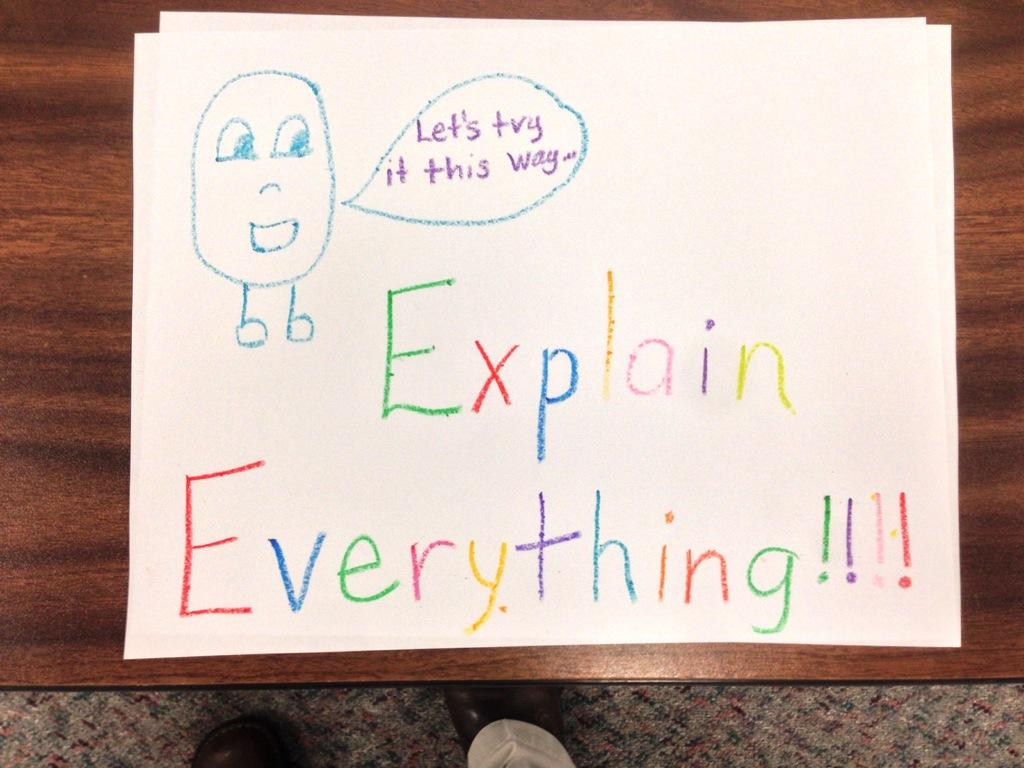<image>
Offer a succinct explanation of the picture presented. A drawing made with crayons that says to explain everything. 